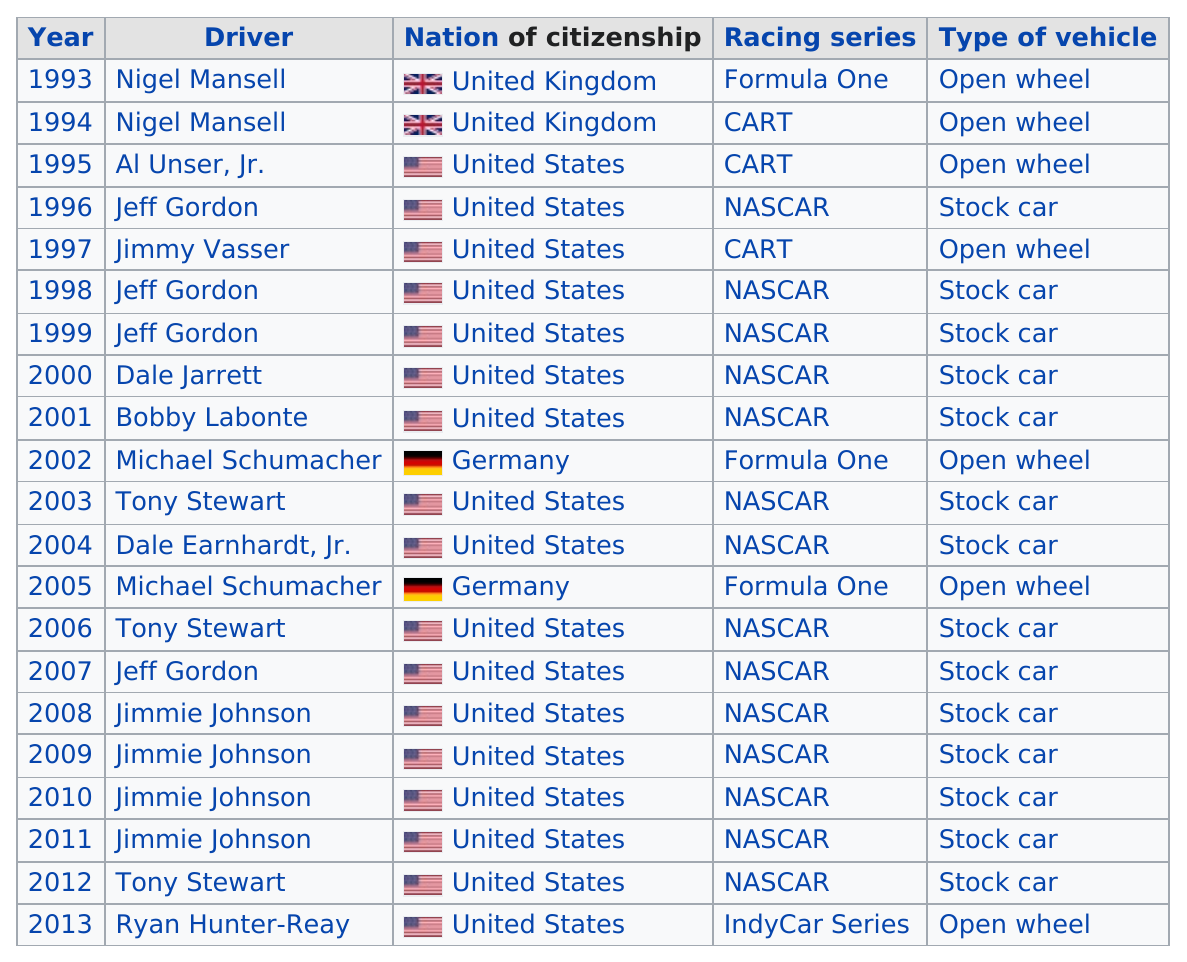Point out several critical features in this image. Jeff Gordon, a professional race car driver, won two ESPY Awards eleven years apart from each other. The United States has more citizenship than the United Kingdom. There are a total of 21 row entries. Out of the drivers named: Nigel Mansell, Al Unser, Jr., Michael Schumacher, and Jeff Gordon, only Al Unser, Jr. has only one ESPY Award. Jeff Gordon won the award four times. 